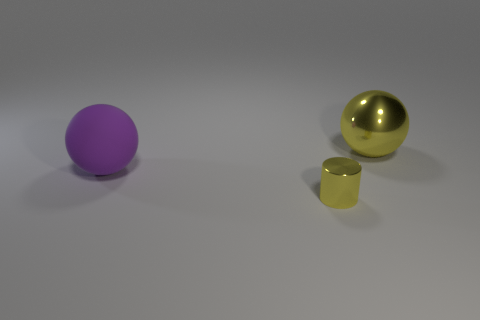Add 1 red matte blocks. How many objects exist? 4 Subtract all cylinders. How many objects are left? 2 Subtract all big yellow spheres. Subtract all big purple matte things. How many objects are left? 1 Add 3 big metal things. How many big metal things are left? 4 Add 1 small gray metal objects. How many small gray metal objects exist? 1 Subtract 0 purple cubes. How many objects are left? 3 